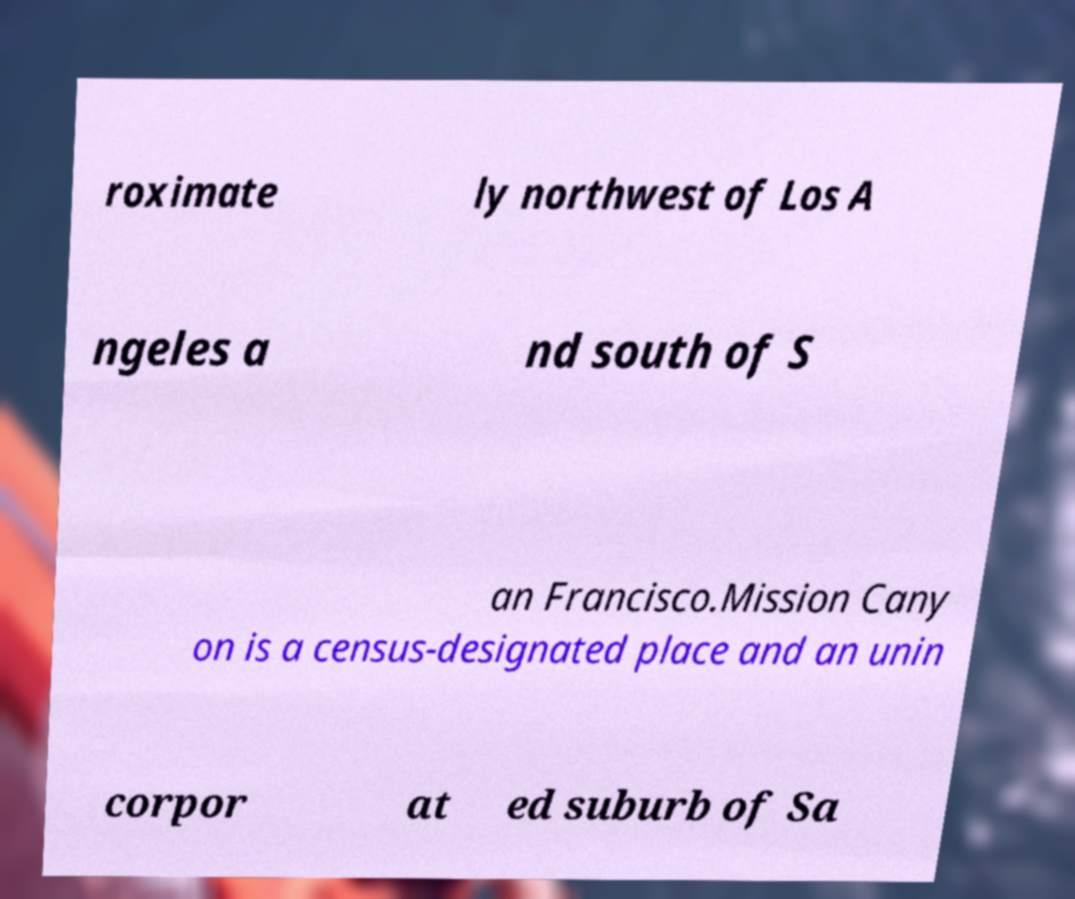There's text embedded in this image that I need extracted. Can you transcribe it verbatim? roximate ly northwest of Los A ngeles a nd south of S an Francisco.Mission Cany on is a census-designated place and an unin corpor at ed suburb of Sa 